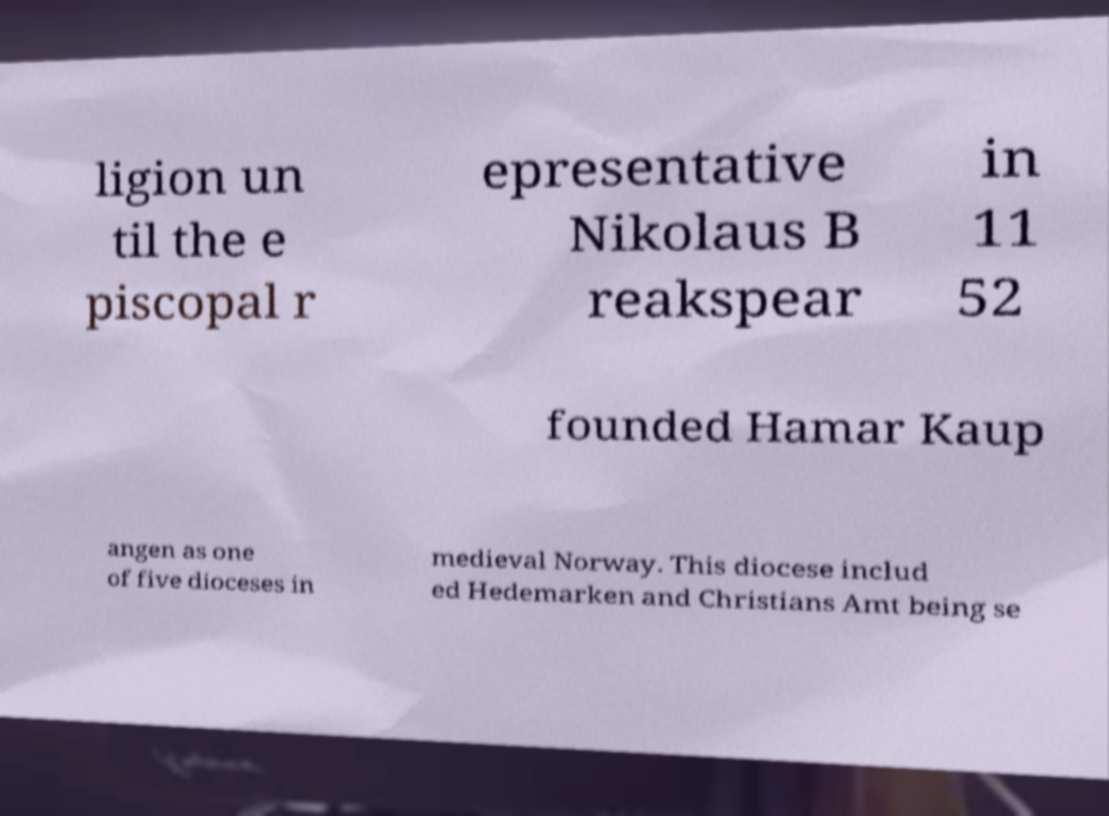Please read and relay the text visible in this image. What does it say? ligion un til the e piscopal r epresentative Nikolaus B reakspear in 11 52 founded Hamar Kaup angen as one of five dioceses in medieval Norway. This diocese includ ed Hedemarken and Christians Amt being se 